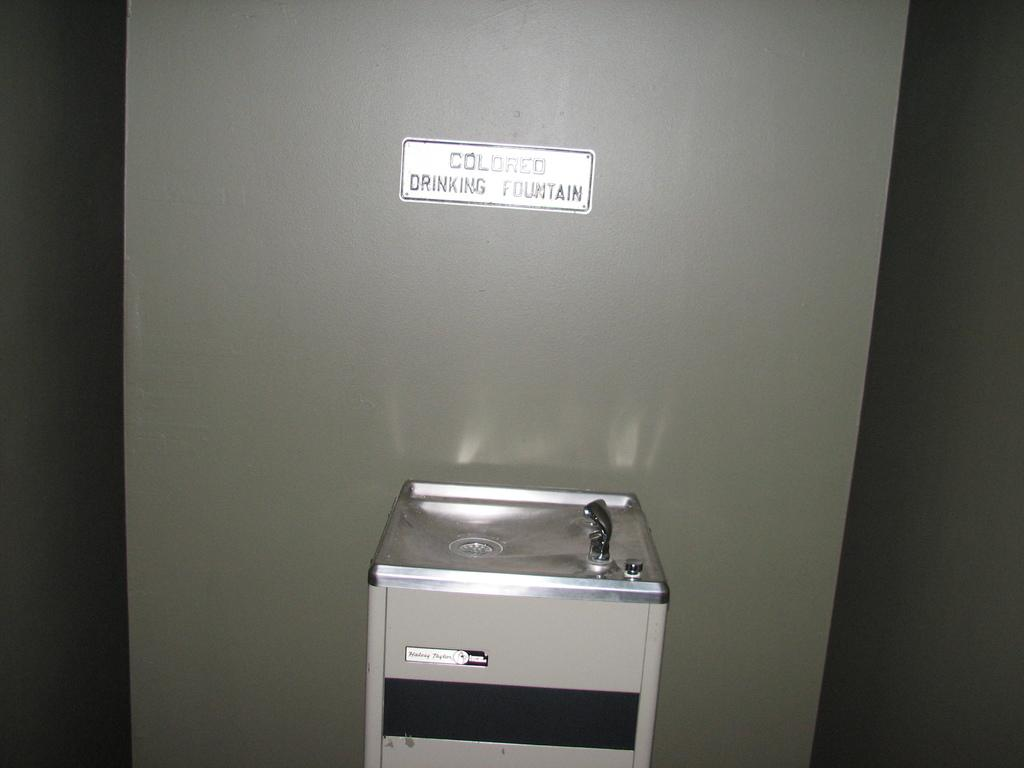Provide a one-sentence caption for the provided image. a COLORED DRINKING FOUNTAIN sign on the wall with the fountain below it. 